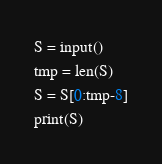<code> <loc_0><loc_0><loc_500><loc_500><_Python_>S = input()
tmp = len(S)
S = S[0:tmp-8]
print(S)</code> 